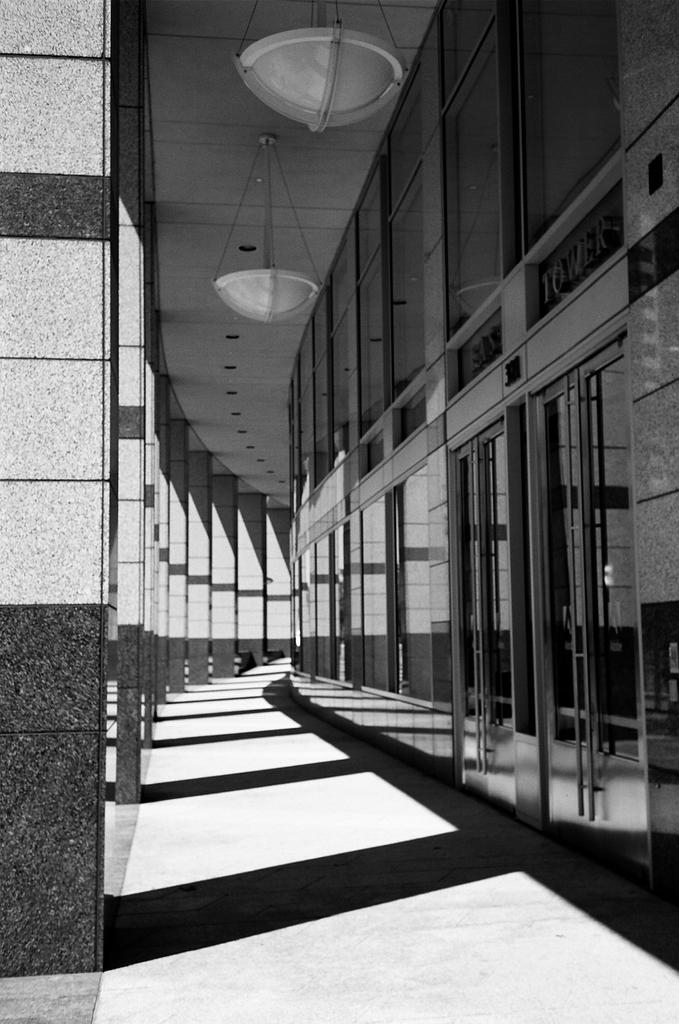What is the color scheme of the image? The image is black and white. What can be seen on the left side of the image? There are pillars on the left side of the image. What type of walls are present in the image? There are glass walls in the image. What is hanging from the ceiling in the image? There are objects hung on the ceiling in the image. How many ducks are swimming in the water in the image? There are no ducks or water present in the image; it features pillars, glass walls, and objects hung on the ceiling. 